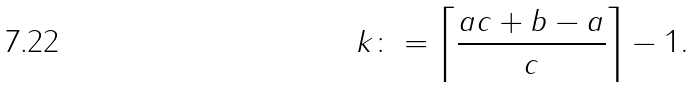Convert formula to latex. <formula><loc_0><loc_0><loc_500><loc_500>k \colon = \left \lceil \frac { a c + b - a } { c } \right \rceil - 1 .</formula> 